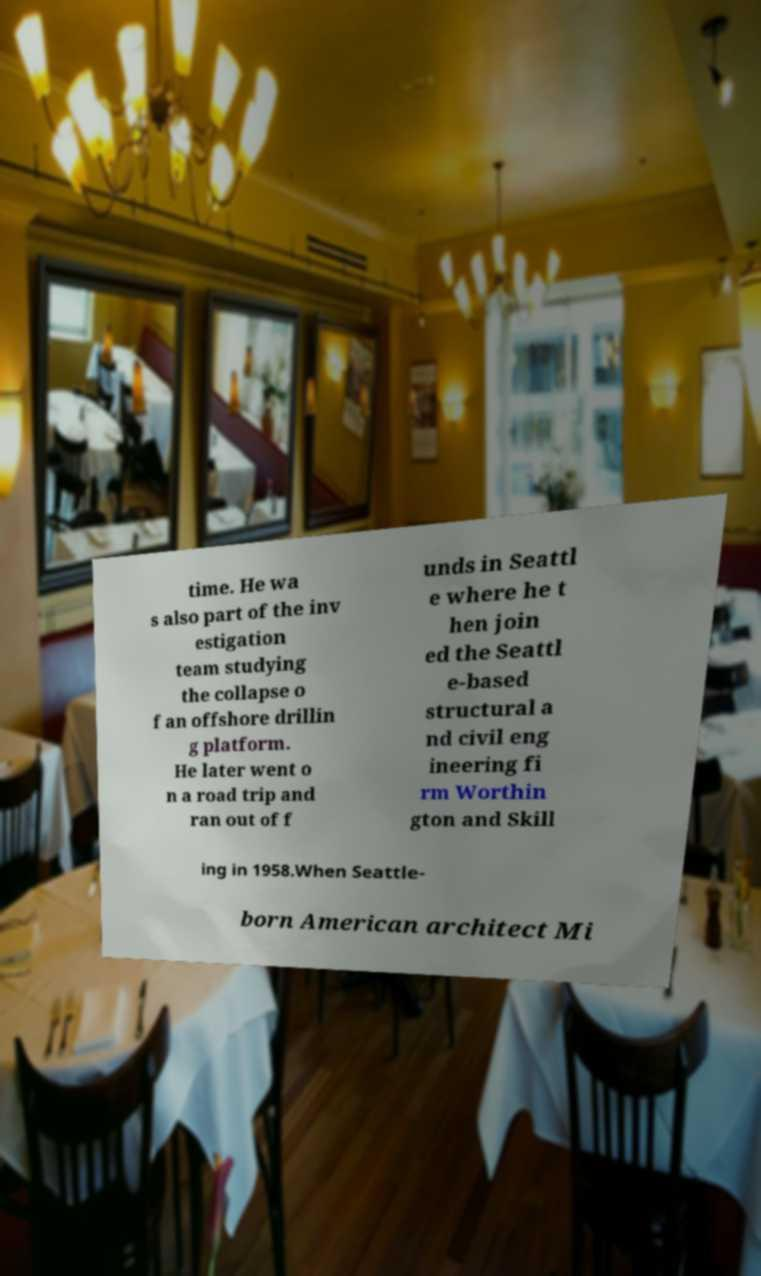For documentation purposes, I need the text within this image transcribed. Could you provide that? time. He wa s also part of the inv estigation team studying the collapse o f an offshore drillin g platform. He later went o n a road trip and ran out of f unds in Seattl e where he t hen join ed the Seattl e-based structural a nd civil eng ineering fi rm Worthin gton and Skill ing in 1958.When Seattle- born American architect Mi 